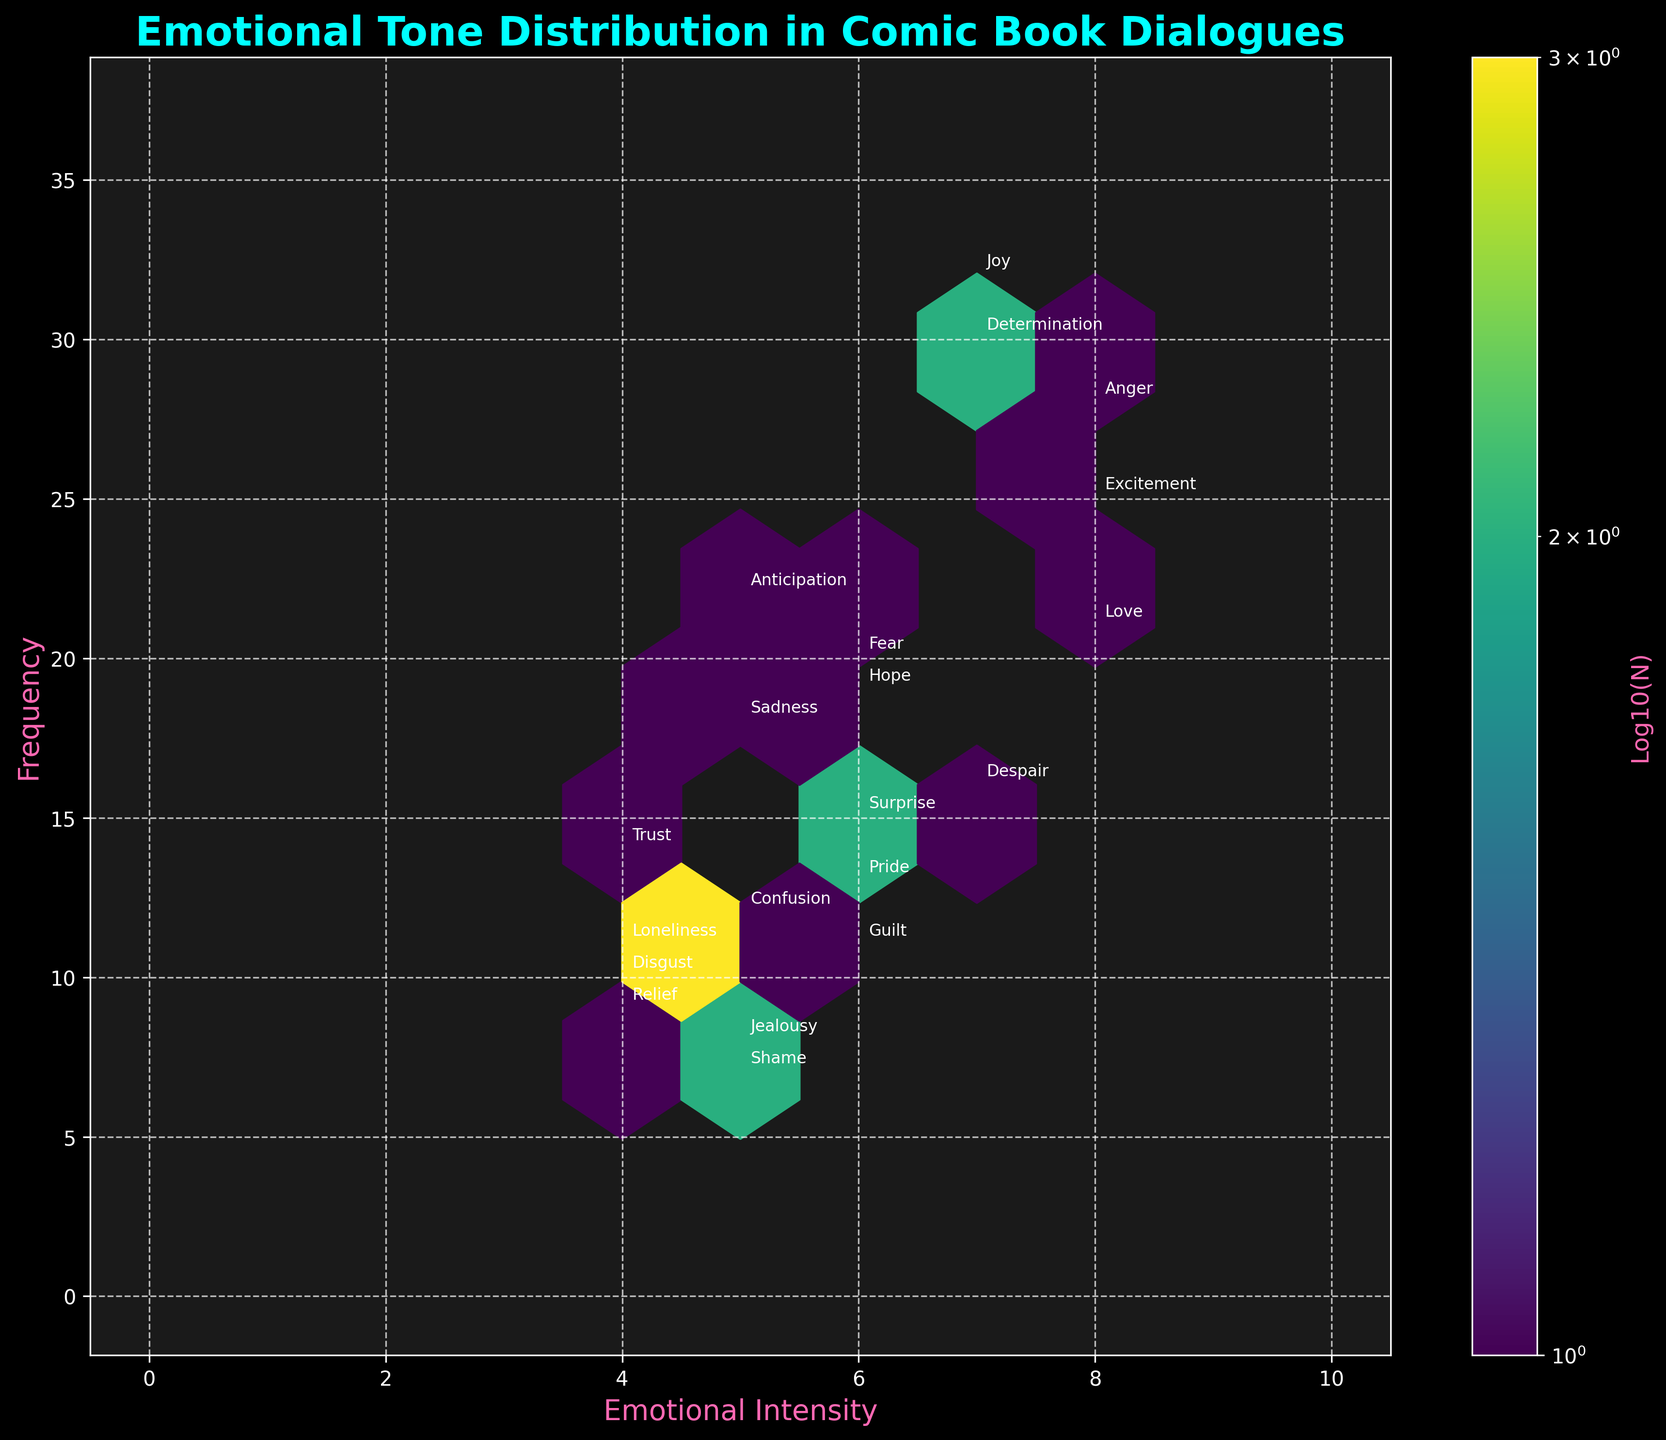How many emotions are displayed on the plot? To determine the number of emotions displayed, we count each unique label annotated on the plot. Since each emotion in the dataset is represented and labeled, the total count of unique labels indicates the number of emotions.
Answer: 20 What is the title of the hexbin plot? The title of the plot is typically displayed prominently at the top. In this case, the title is centered and set in a larger font size, making it easy to identify.
Answer: Emotional Tone Distribution in Comic Book Dialogues Which emotion has the highest frequency according to the plot? To find the emotion with the highest frequency, look at the y-axis values and identify which annotation corresponds to the highest point. Reading the labels reveals that the emotion with the highest value on the y-axis (frequency) is Joy, with a frequency of 32.
Answer: Joy What is the range of emotional intensities displayed on the x-axis? The range of the emotional intensities can be determined by examining the x-axis, which shows the scale of intensities from the minimum to the maximum values used in the plot. The labels cover intensities from 0 to 10.
Answer: 0 to 10 Where on the hexbin plot is the emotion “Anger” located in terms of intensity and frequency? To locate "Anger," find its label on the plot and refer to its coordinates. The x-axis provides the intensity, and the y-axis provides the frequency for this label. "Anger" is annotated around (8, 28).
Answer: (8, 28) Which emotions have an intensity of 4? The emotions with an intensity of 4 can be identified by locating labels positioned at the intensity value of 4 on the x-axis and checking corresponding frequency values against annotations. The emotions are Disgust, Trust, Relief, and Loneliness.
Answer: Disgust, Trust, Relief, Loneliness What’s the emotional intensity and frequency for “Love”? Look for the annotation “Love” on the plot. Its positioning along the x and y axes will indicate its emotional intensity and frequency. “Love” is around the coordinates (8, 21).
Answer: (8, 21) Compare the frequency of “Joy” and “Sadness.” Which is more frequent, and by how much? To compare, find the y-axis values for "Joy" and "Sadness." "Joy" has a frequency of 32, while "Sadness" stands at 18. The difference is calculated as 32 - 18 = 14.
Answer: Joy by 14 What is the median emotional intensity from the data shown on the plot? List out all the intensities: (7, 8, 6, 5, 6, 4, 5, 4, 6, 7, 8, 5, 7, 6, 4, 5, 6, 5, 4, 8). Arrange them in ascending order: (4, 4, 4, 4, 5, 5, 5, 5, 6, 6, 6, 6, 6, 7, 7, 7, 8, 8, 8, 8). The middle value or median is the average of the 10th and 11th values, which are both 6.
Answer: 6 Identify any outliers in the data shown on the hexbin plot. Outliers are data points significantly distant from others in the plot. Scanning annotations and patterns, no single emotion drastically deviates from the others given the range. The emotions cover a broad but continuous range, suggesting no significant outliers.
Answer: None 